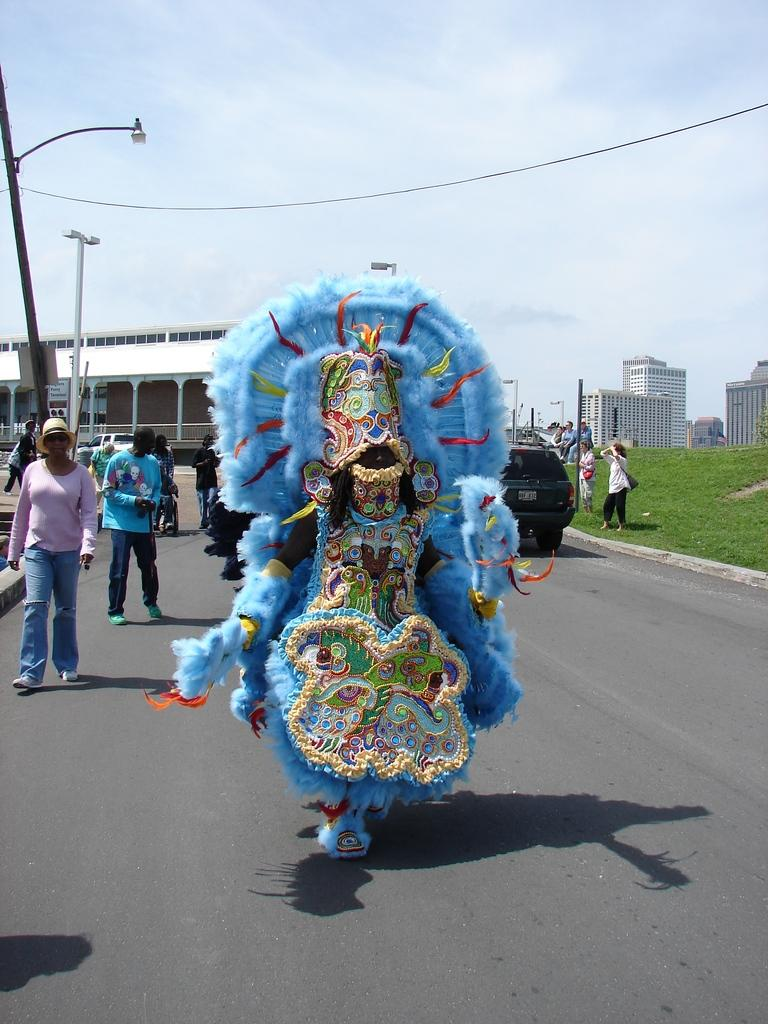What is the main subject in the center of the image? There is a clown in the center of the image. Are there any other people in the image besides the clown? Yes, there are people in the image. What can be seen on the road in the image? There is a car on the road in the image. What is visible in the background of the image? There are buildings, boards, and the sky visible in the background of the image. Can you describe the wire in the image? There is a wire in the image, but its specific purpose or function is not clear from the provided facts. What route does the clown take to reach the place in the image? There is no information about the clown's route or destination in the image, so it cannot be determined. 